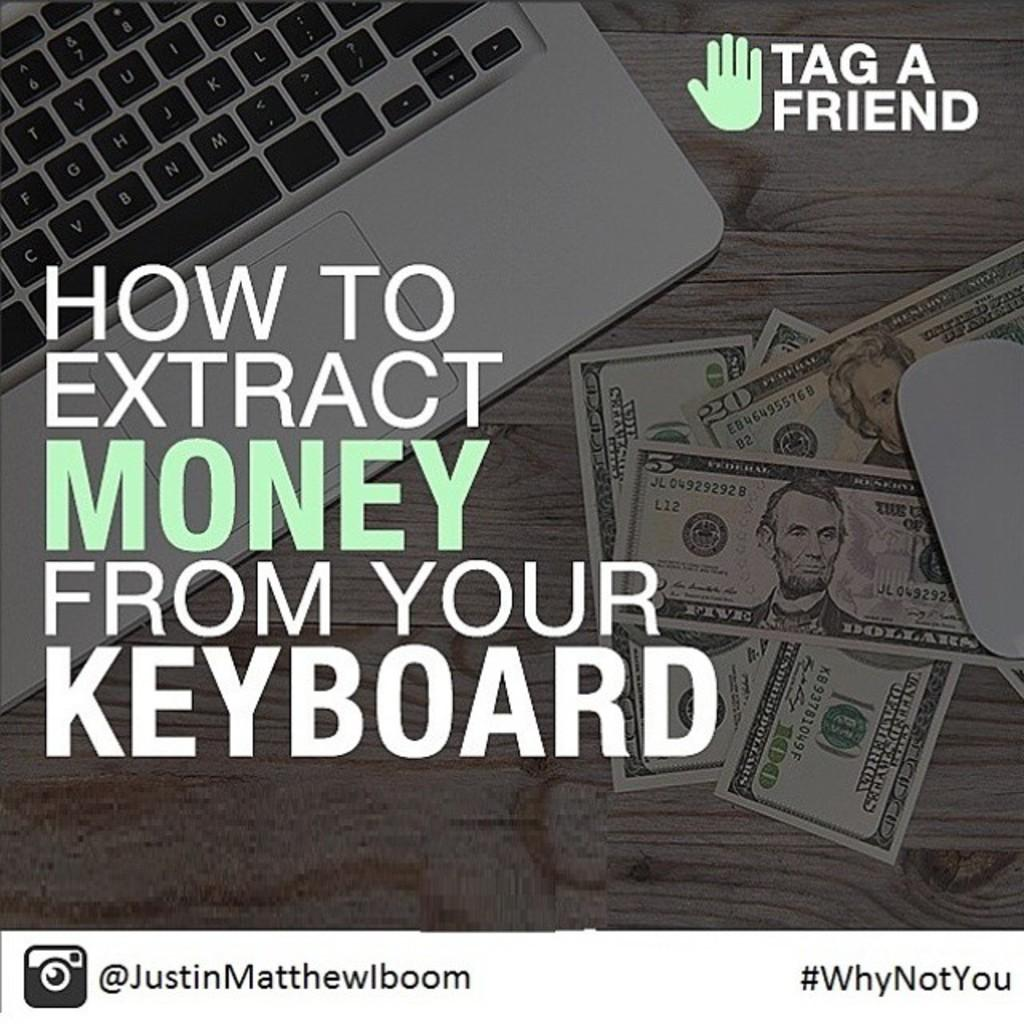What is the main subject of the image? There is an advertisement in the image. What is featured in the advertisement? The advertisement contains a laptop and money. Is there any text present in the advertisement? Yes, there is text in the advertisement. What type of agreement is being made in the image? There is no agreement being made in the image; it is an advertisement featuring a laptop and money. What stage of development is shown in the image? The image does not depict any development process; it is an advertisement with a laptop, money, and text. 